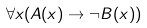Convert formula to latex. <formula><loc_0><loc_0><loc_500><loc_500>\forall x ( A ( x ) \rightarrow \neg B ( x ) )</formula> 